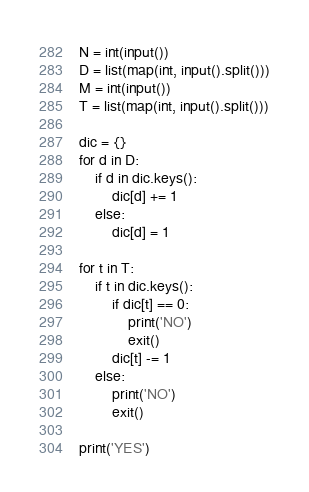Convert code to text. <code><loc_0><loc_0><loc_500><loc_500><_Python_>N = int(input())
D = list(map(int, input().split()))
M = int(input())
T = list(map(int, input().split()))

dic = {}
for d in D:
    if d in dic.keys():
        dic[d] += 1
    else:
        dic[d] = 1

for t in T:
    if t in dic.keys():
        if dic[t] == 0:
            print('NO')
            exit()
        dic[t] -= 1
    else:
        print('NO')
        exit()

print('YES')
</code> 